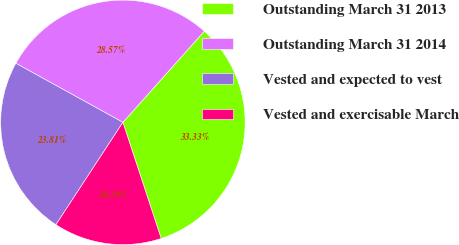<chart> <loc_0><loc_0><loc_500><loc_500><pie_chart><fcel>Outstanding March 31 2013<fcel>Outstanding March 31 2014<fcel>Vested and expected to vest<fcel>Vested and exercisable March<nl><fcel>33.33%<fcel>28.57%<fcel>23.81%<fcel>14.29%<nl></chart> 